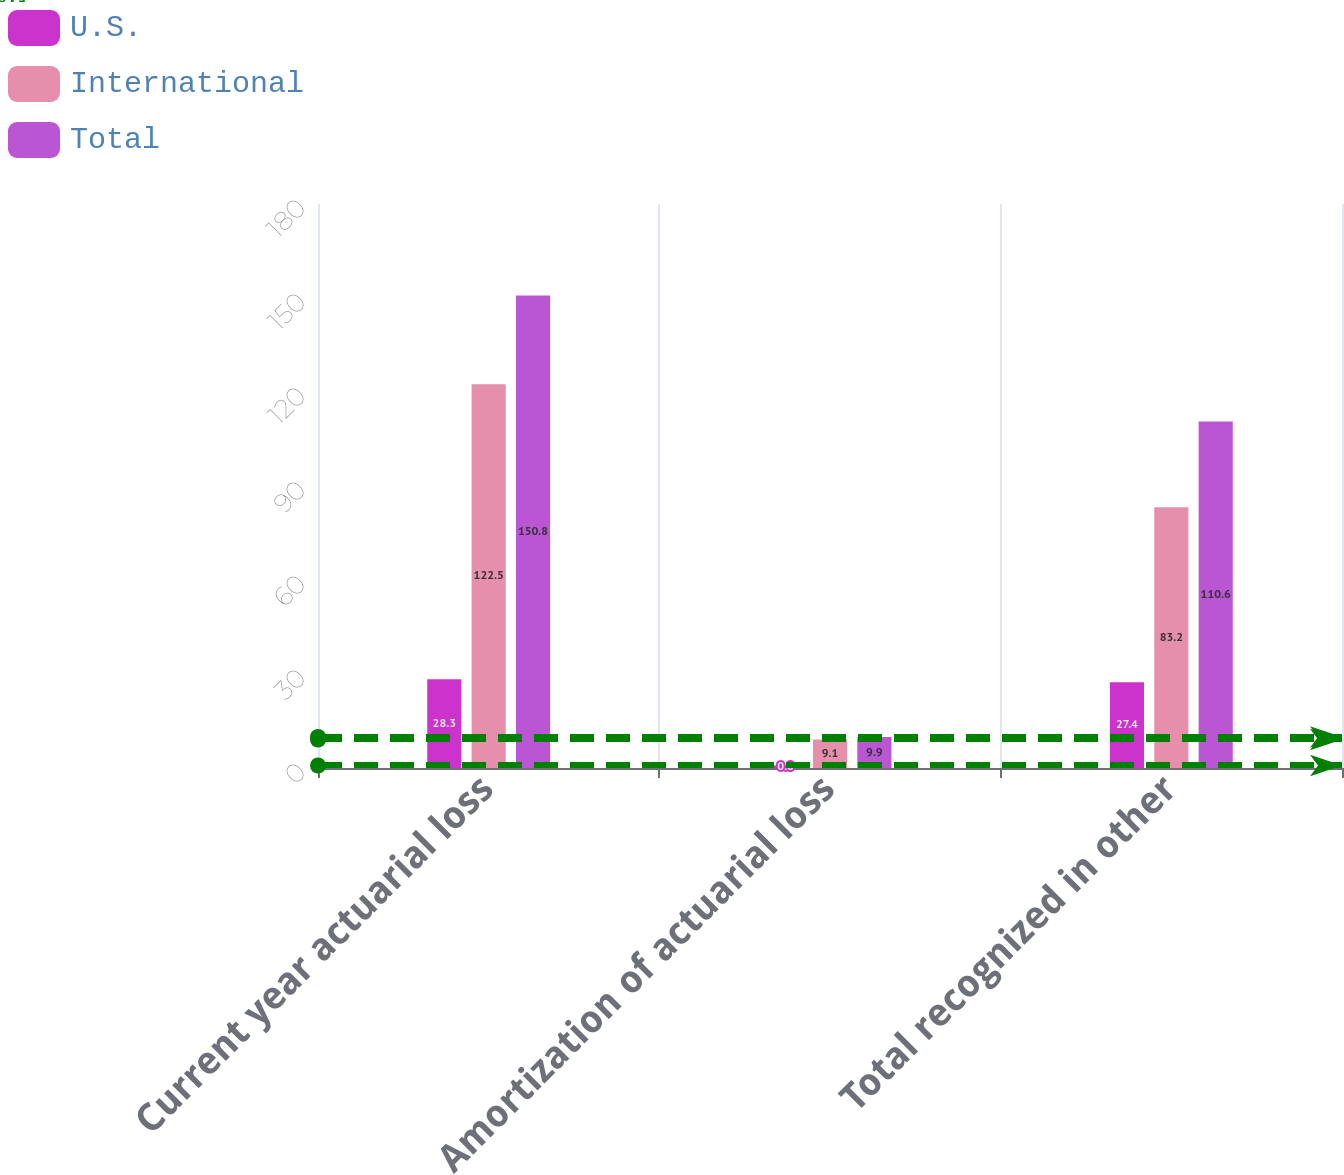Convert chart. <chart><loc_0><loc_0><loc_500><loc_500><stacked_bar_chart><ecel><fcel>Current year actuarial loss<fcel>Amortization of actuarial loss<fcel>Total recognized in other<nl><fcel>U.S.<fcel>28.3<fcel>0.8<fcel>27.4<nl><fcel>International<fcel>122.5<fcel>9.1<fcel>83.2<nl><fcel>Total<fcel>150.8<fcel>9.9<fcel>110.6<nl></chart> 